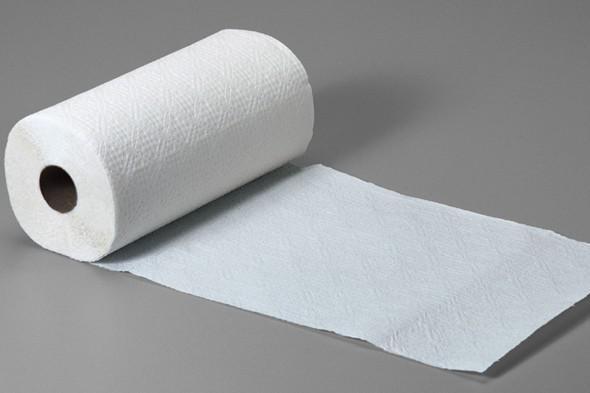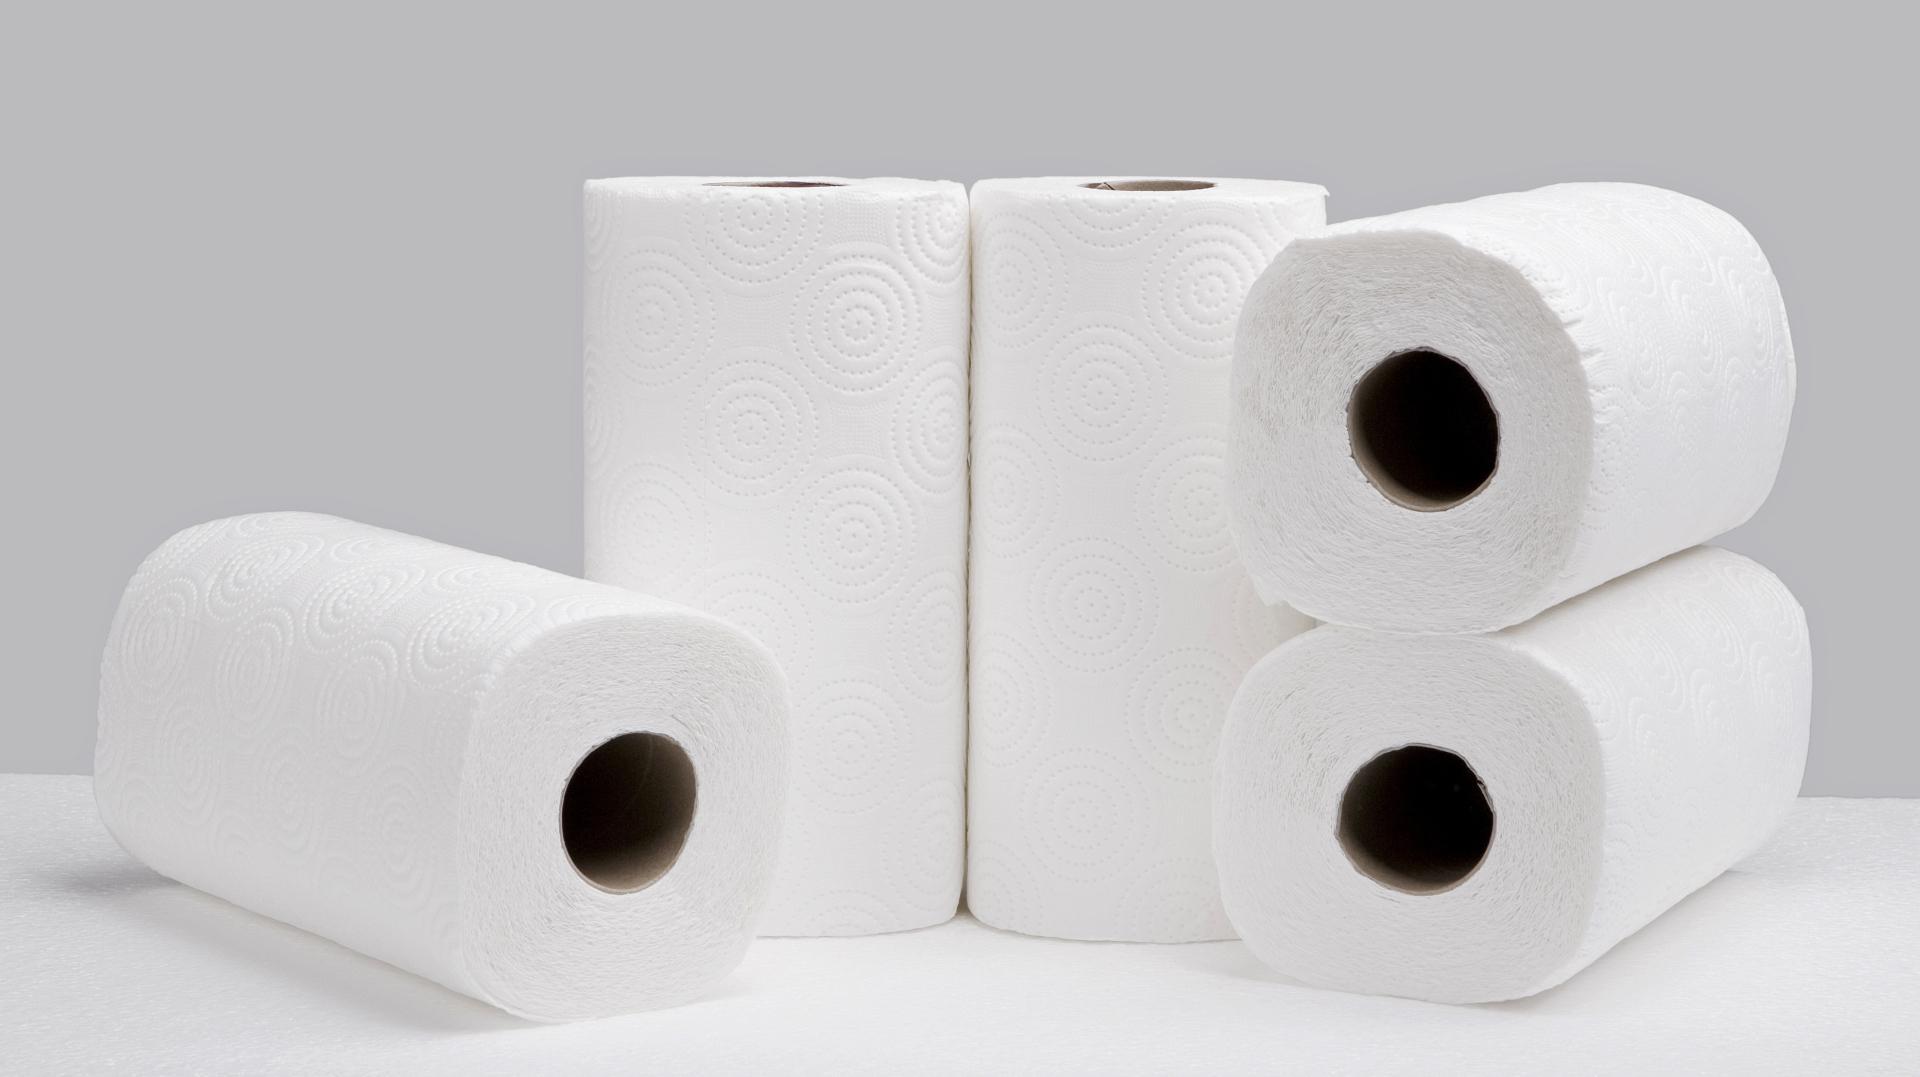The first image is the image on the left, the second image is the image on the right. Considering the images on both sides, is "An image shows only flat, folded paper towels." valid? Answer yes or no. No. The first image is the image on the left, the second image is the image on the right. Considering the images on both sides, is "All paper towels are white and on rolls." valid? Answer yes or no. Yes. 